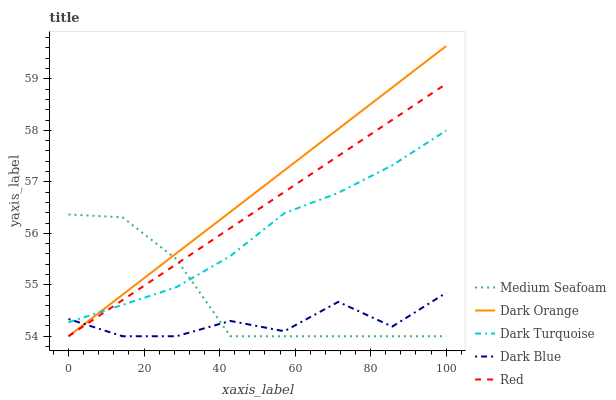Does Dark Blue have the minimum area under the curve?
Answer yes or no. Yes. Does Dark Orange have the maximum area under the curve?
Answer yes or no. Yes. Does Medium Seafoam have the minimum area under the curve?
Answer yes or no. No. Does Medium Seafoam have the maximum area under the curve?
Answer yes or no. No. Is Red the smoothest?
Answer yes or no. Yes. Is Dark Blue the roughest?
Answer yes or no. Yes. Is Medium Seafoam the smoothest?
Answer yes or no. No. Is Medium Seafoam the roughest?
Answer yes or no. No. Does Dark Orange have the lowest value?
Answer yes or no. Yes. Does Dark Turquoise have the lowest value?
Answer yes or no. No. Does Dark Orange have the highest value?
Answer yes or no. Yes. Does Medium Seafoam have the highest value?
Answer yes or no. No. Does Red intersect Dark Blue?
Answer yes or no. Yes. Is Red less than Dark Blue?
Answer yes or no. No. Is Red greater than Dark Blue?
Answer yes or no. No. 